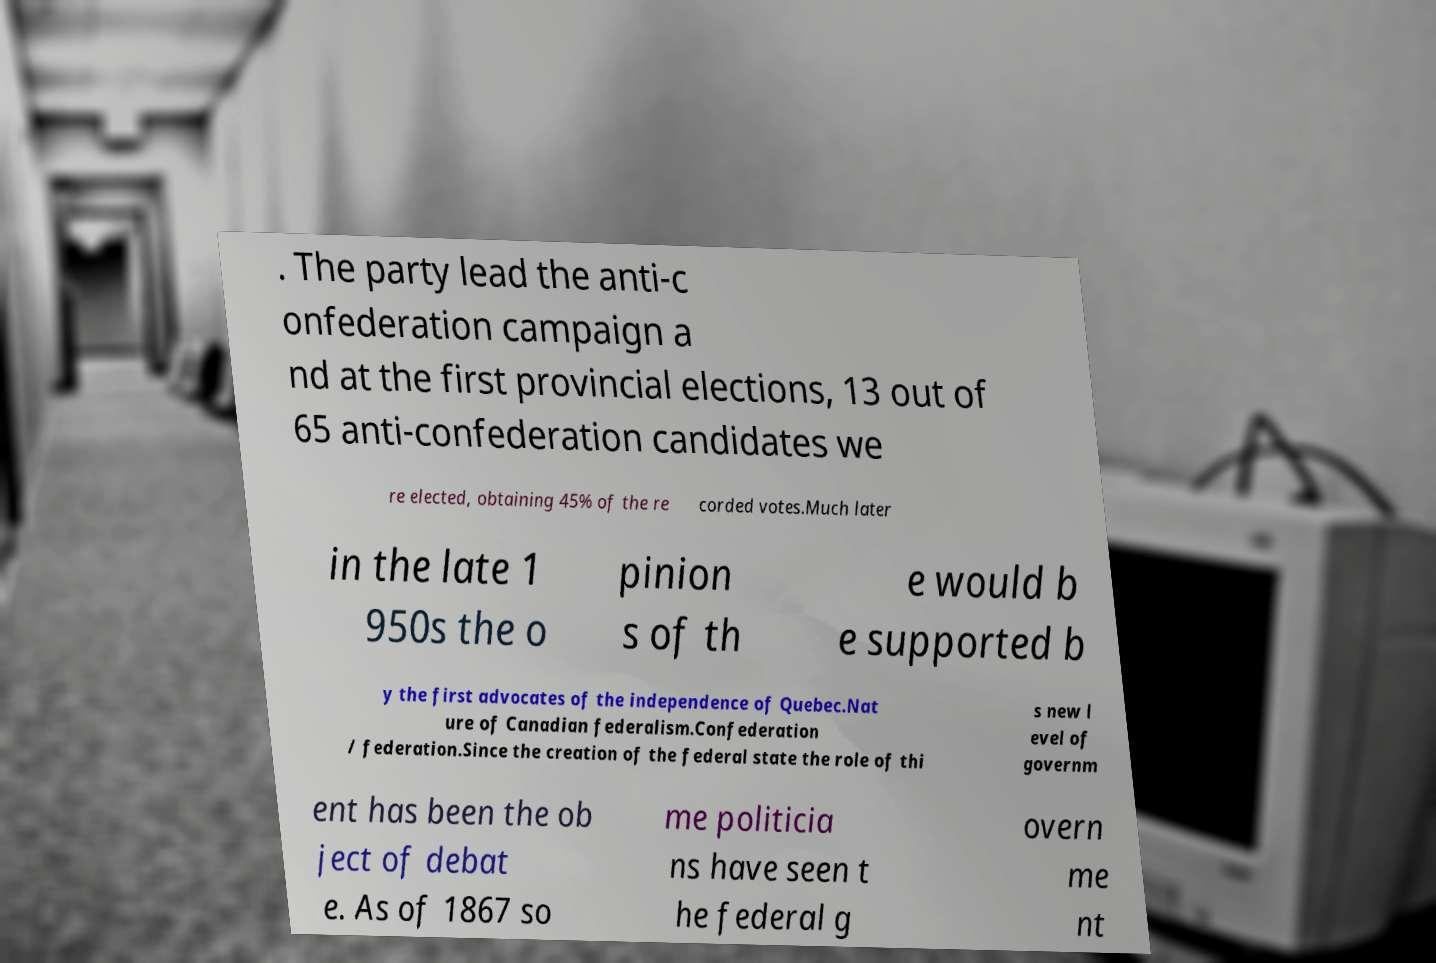Please read and relay the text visible in this image. What does it say? . The party lead the anti-c onfederation campaign a nd at the first provincial elections, 13 out of 65 anti-confederation candidates we re elected, obtaining 45% of the re corded votes.Much later in the late 1 950s the o pinion s of th e would b e supported b y the first advocates of the independence of Quebec.Nat ure of Canadian federalism.Confederation / federation.Since the creation of the federal state the role of thi s new l evel of governm ent has been the ob ject of debat e. As of 1867 so me politicia ns have seen t he federal g overn me nt 